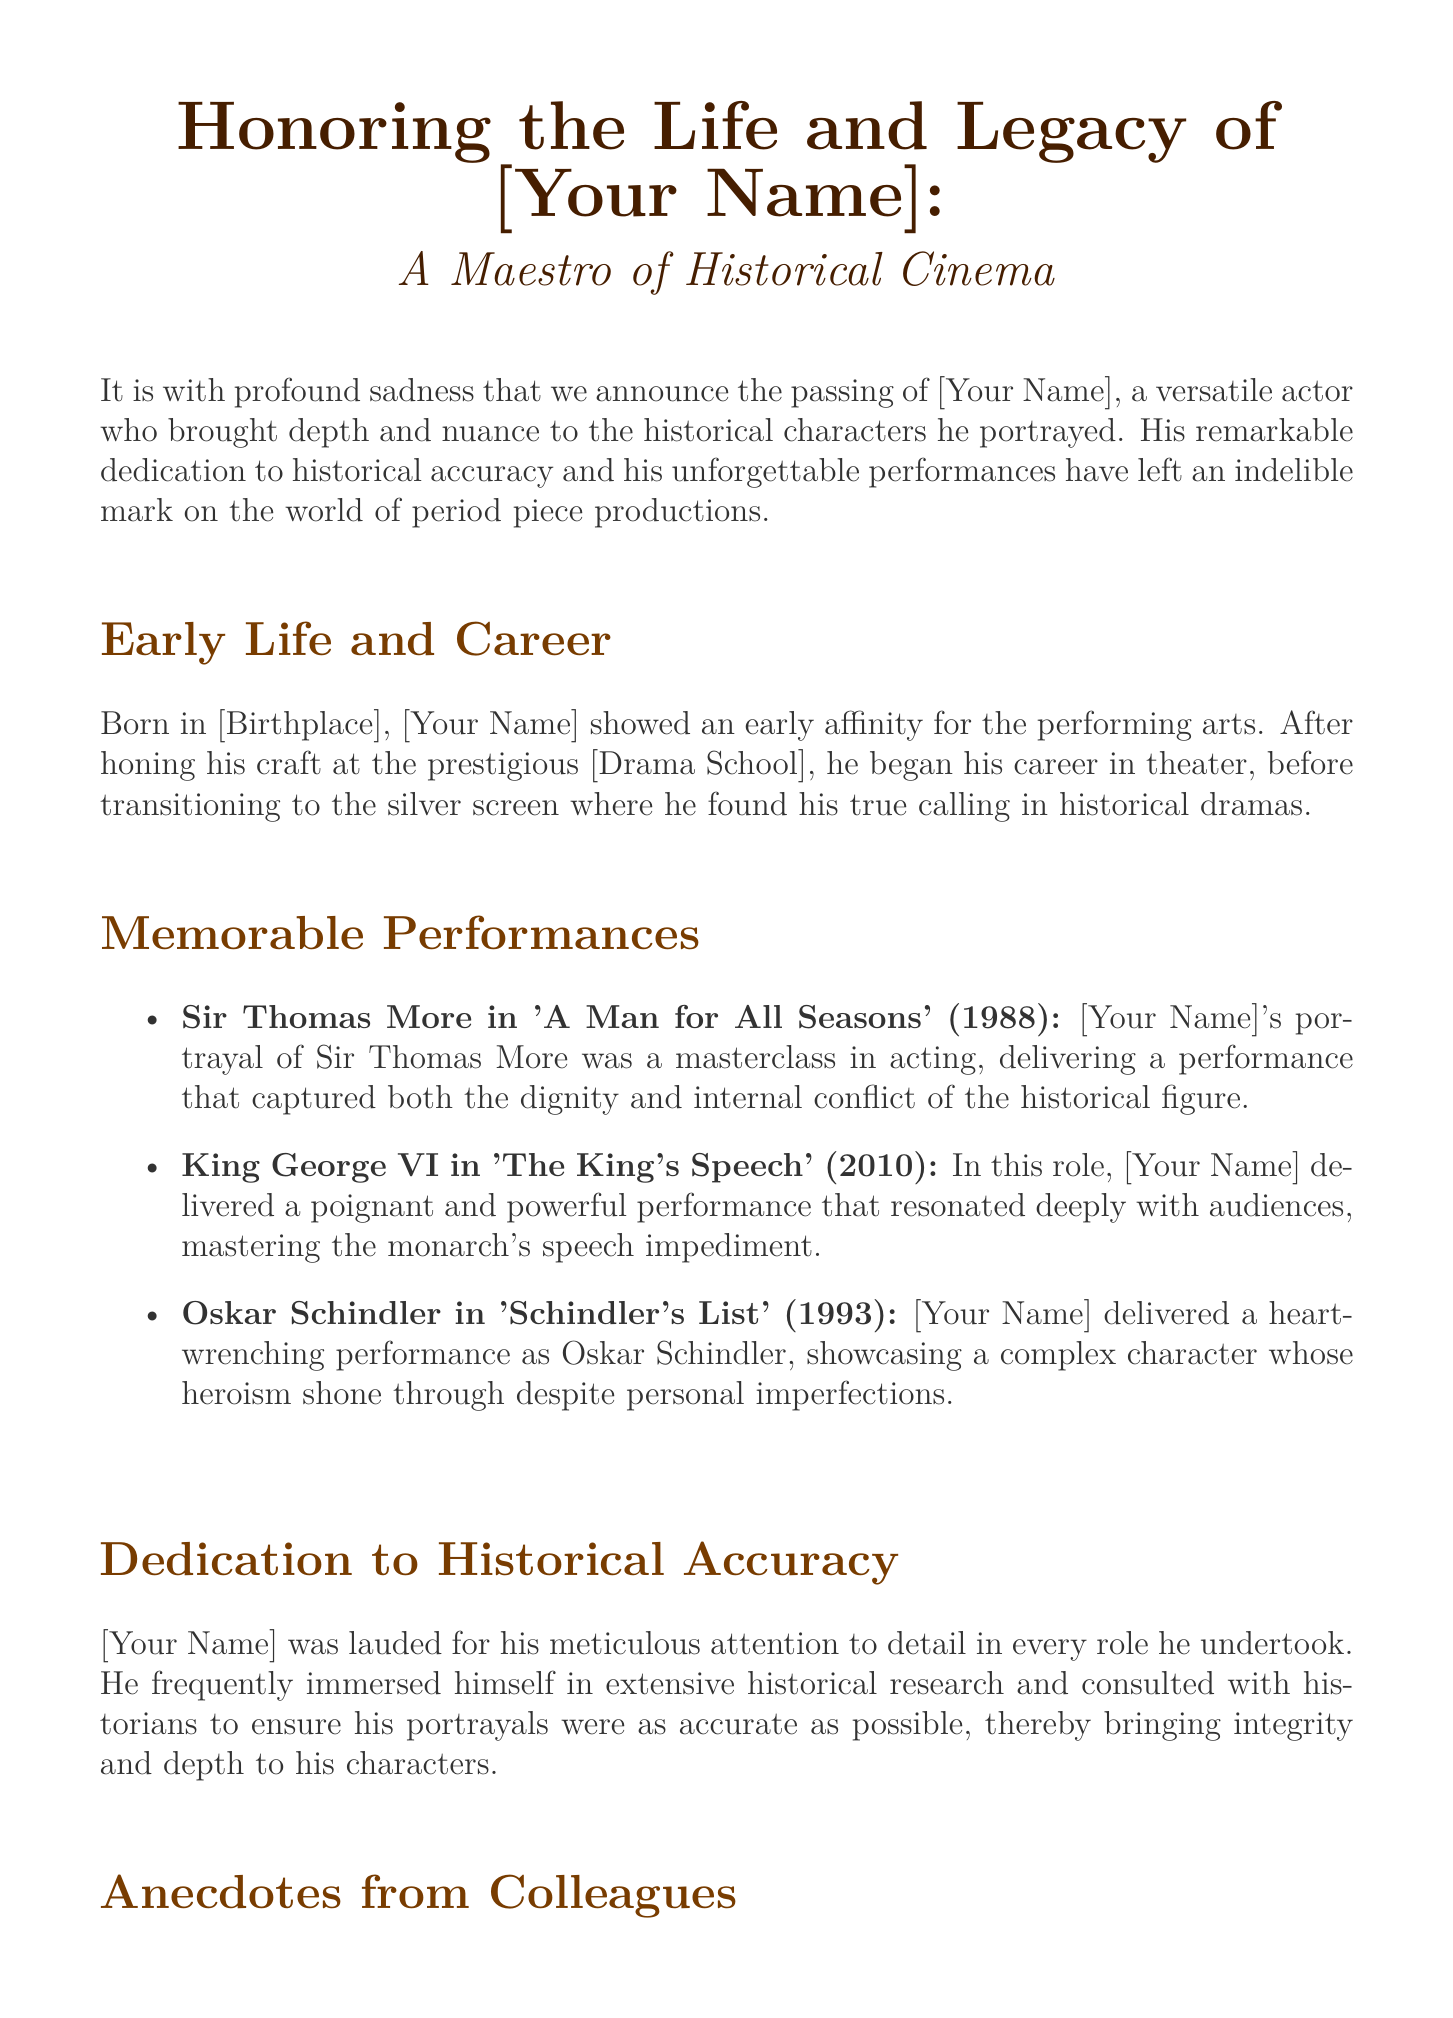What was [Your Name]'s role in 'A Man for All Seasons'? The document states that [Your Name] portrayed Sir Thomas More in 'A Man for All Seasons'.
Answer: Sir Thomas More What year was 'The King's Speech' released? The document mentions that 'The King's Speech' was released in 2010.
Answer: 2010 Who remarked on [Your Name]'s authenticity in 'Schindler's List'? The document states that the director Steven Spielberg remarked on [Your Name]'s authenticity in 'Schindler's List'.
Answer: Steven Spielberg What is [Your Name]'s birth location? The document mentions that [Your Name] was born in [Birthplace].
Answer: [Birthplace] How did [Your Name] approach historical accuracy? The document describes that [Your Name] immersed himself in extensive historical research and consulted with historians.
Answer: Extensive historical research What aspect of [Your Name]'s performance resonated with audiences in 'The King's Speech'? The document states that [Your Name] delivered a poignant and powerful performance in 'The King's Speech'.
Answer: Poignant and powerful performance What type of productions was [Your Name] most known for? The document indicates that [Your Name] was known for his significant contributions to period piece productions.
Answer: Period piece productions What did Colin Firth comment about [Your Name]'s character portrayal? The document states that Colin Firth was in awe of [Your Name]'s process and passion for his characters.
Answer: In awe of his process Which historical figure did [Your Name] depict in 'Schindler's List'? The document specifies that [Your Name] portrayed Oskar Schindler in 'Schindler's List'.
Answer: Oskar Schindler 